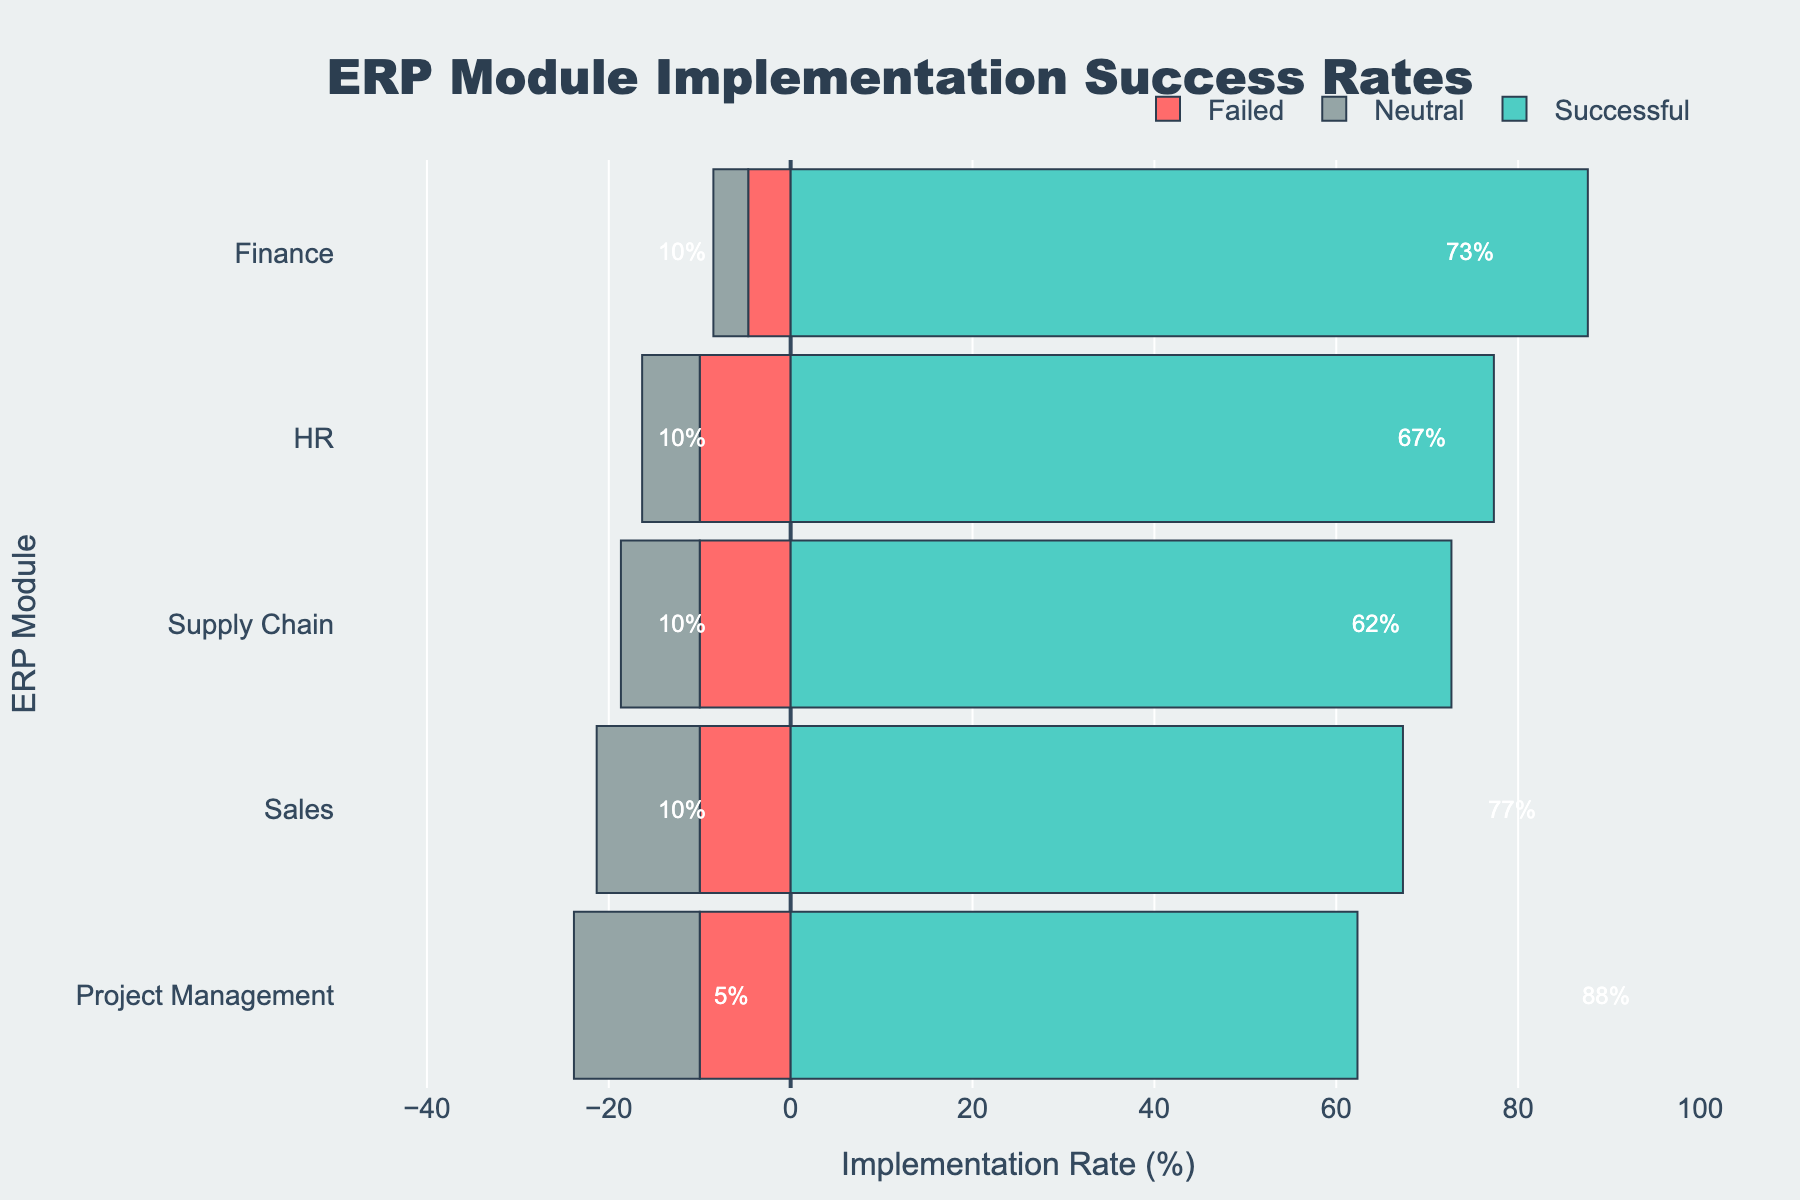What percentage of Project Management implementations were successful? From the figure, locate the percentage value labeled on the right side of the Project Management bar under the green section. This section represents successful implementations.
Answer: 62% Between Finance and HR, which module has a higher rate of neutral implementation outcomes? Observe the gray section (representing neutral outcomes) for both Finance and HR modules. Compare their lengths visually or refer to the percentage values.
Answer: HR What is the combined rate of successful and failed implementations for the Supply Chain module? Add the percentage of successful (green section) and failed (red section) implementations from the Supply Chain module. Successful is 73% and failed is 10%, so 73 + 10 = 83%.
Answer: 83% Which module has the smallest difference between its successful and failed implementation rates? Calculate the difference between successful (green section) and failed (red section) implementation rates for each module and compare to find the smallest difference. Finance has 88% - 4% = 84%, HR has 77% - 10% = 67%, Supply Chain has 73% - 10% = 63%, Sales has 67% - 10% = 57%, and Project Management has 62% - 10% = 52%. Project Management has the smallest difference.
Answer: Project Management How do the neutral implementation rates for Finance and Sales compare visually? Compare the lengths of the gray bars representing neutral implementation rates for Finance and Sales modules. The Sales module has a longer gray bar than the Finance module, indicating a higher neutral rate.
Answer: Sales has a higher neutral rate Which ERP module has the highest success rate? Look for the green section that extends the farthest to the right. The green section for Finance is the longest compared to other modules.
Answer: Finance What is the average successful implementation rate across all modules? Sum the successful implementation percentages of all modules (85 + 75 + 70 + 65 + 60 + 90 + 80 + 75 + 70 + 65 + 88 + 77 + 73 + 67 + 62) and divide by the total number of modules (15). Total = 1132. 1132 ÷ 15 = 75.47%.
Answer: 75.47% Is the failure rate higher for Sales or HR modules? Compare the red sections of Sales and HR modules. Both have a failed implementation rate of 10%, as represented by the length of the red bars.
Answer: Equal 